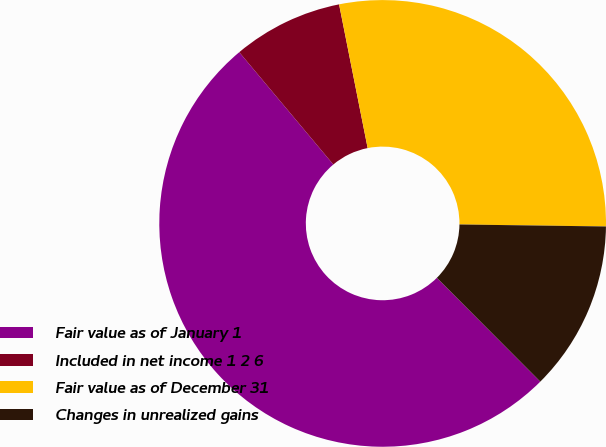Convert chart. <chart><loc_0><loc_0><loc_500><loc_500><pie_chart><fcel>Fair value as of January 1<fcel>Included in net income 1 2 6<fcel>Fair value as of December 31<fcel>Changes in unrealized gains<nl><fcel>51.37%<fcel>7.97%<fcel>28.34%<fcel>12.31%<nl></chart> 